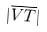<formula> <loc_0><loc_0><loc_500><loc_500>| \overline { V T } |</formula> 